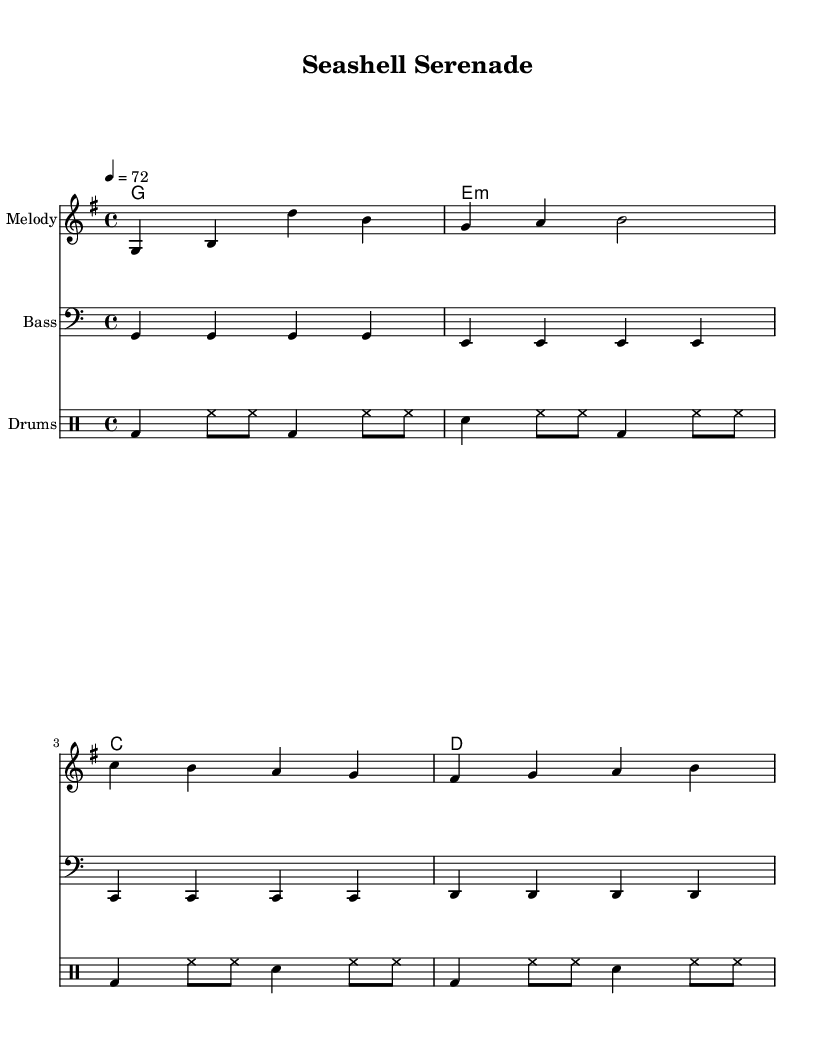What is the key signature of this music? The key signature is G major, which has one sharp (F#).
Answer: G major What is the time signature of this music? The time signature is 4/4, indicating four beats in a measure.
Answer: 4/4 What is the tempo marking indicated in the music? The tempo marking is 4 = 72, which means the quarter note should be played at a speed of 72 beats per minute.
Answer: 72 What is the first chord in the progression? The first chord in the progression is G major, identified at the beginning of the chord line as "g1".
Answer: G How many measures are in the melody section? The melody section has four measures, each separated by bar lines. Count the groups of notes to find there are four spans.
Answer: 4 What type of rhythmic feel does this music embody? The music embodies a laid-back, relaxed feel typical of reggae, highlighted by the use of off-beat rhythms and slower tempo.
Answer: Laid-back Which clef is used for the bass line? The bass line uses the bass clef, which is specifically indicated at the beginning of the bass line staff.
Answer: Bass 